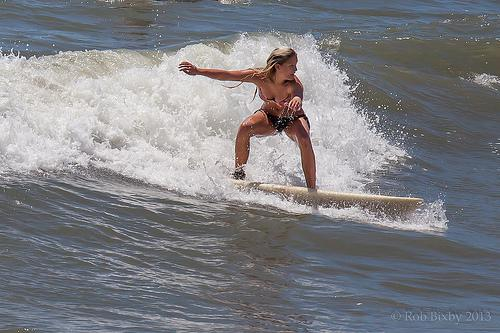Question: who is the girl?
Choices:
A. A swimmer.
B. A lifeguard.
C. A surfer.
D. A policewoman.
Answer with the letter. Answer: C Question: what is the color of the waves?
Choices:
A. White.
B. Black.
C. Magenta.
D. Gold.
Answer with the letter. Answer: A Question: how many people are shown?
Choices:
A. Two.
B. One.
C. Three.
D. Four.
Answer with the letter. Answer: B Question: what is the woman doing?
Choices:
A. Texting.
B. Yoga.
C. Surfing.
D. Swimming.
Answer with the letter. Answer: C Question: where is the person?
Choices:
A. On the beach.
B. On board.
C. In the air.
D. Under the boardwalk.
Answer with the letter. Answer: B 